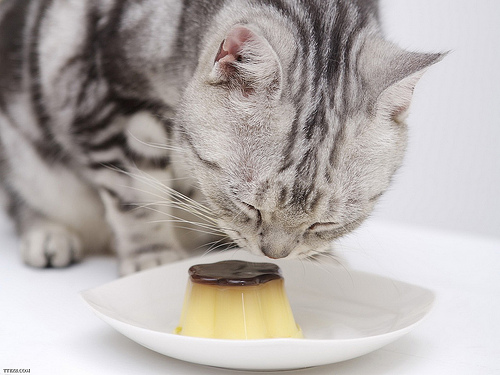Please provide the bounding box coordinate of the region this sentence describes: stripes on the cat. The cat's striped pattern, featuring a mix of gray tones, can be found primarily along its back, with the bounding box encompassing these markings at [0.53, 0.12, 0.74, 0.54]. 